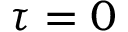<formula> <loc_0><loc_0><loc_500><loc_500>\tau = 0</formula> 